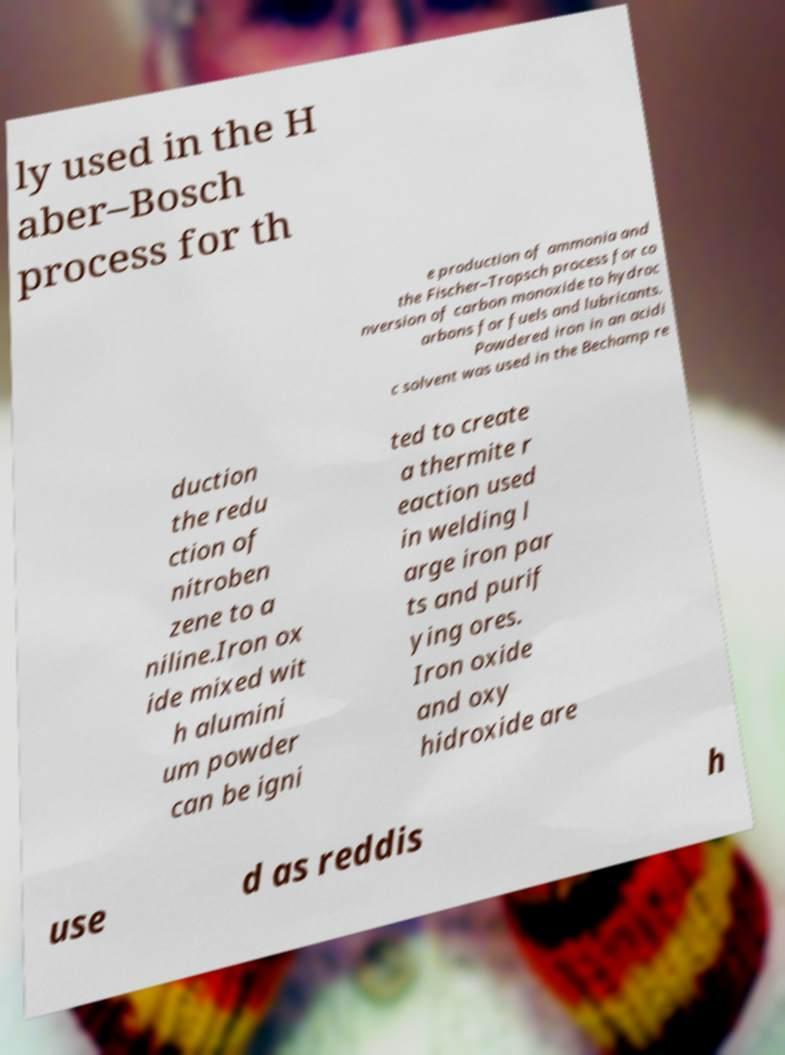Can you read and provide the text displayed in the image?This photo seems to have some interesting text. Can you extract and type it out for me? ly used in the H aber–Bosch process for th e production of ammonia and the Fischer–Tropsch process for co nversion of carbon monoxide to hydroc arbons for fuels and lubricants. Powdered iron in an acidi c solvent was used in the Bechamp re duction the redu ction of nitroben zene to a niline.Iron ox ide mixed wit h alumini um powder can be igni ted to create a thermite r eaction used in welding l arge iron par ts and purif ying ores. Iron oxide and oxy hidroxide are use d as reddis h 